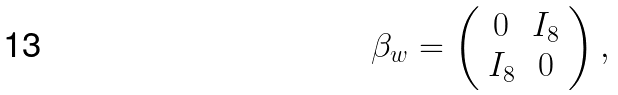Convert formula to latex. <formula><loc_0><loc_0><loc_500><loc_500>\beta _ { w } = \left ( \begin{array} { c c } 0 & I _ { 8 } \\ I _ { 8 } & 0 \end{array} \right ) ,</formula> 